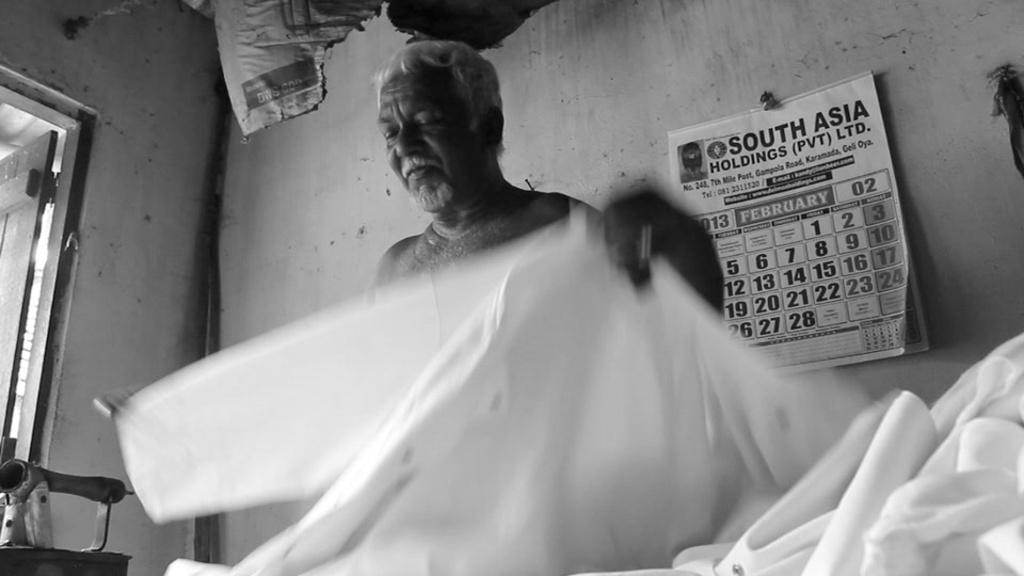Who or what is the main subject of the image? There is a person in the image. What is the person holding in the image? The person is holding a cloth. What can be seen on the wall in the background of the image? There is a calendar attached to a wall in the background. What color scheme is used in the image? The image is in black and white. What type of patch is sewn onto the person's clothing in the image? There is no patch visible on the person's clothing in the image. What kind of cream is being applied to the person's face in the image? There is no cream being applied to the person's face in the image. 